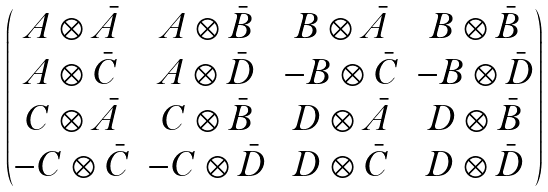Convert formula to latex. <formula><loc_0><loc_0><loc_500><loc_500>\begin{pmatrix} A \otimes \bar { A } & A \otimes \bar { B } & B \otimes \bar { A } & B \otimes \bar { B } \\ A \otimes \bar { C } & A \otimes \bar { D } & - B \otimes \bar { C } & - B \otimes \bar { D } \\ C \otimes \bar { A } & C \otimes \bar { B } & D \otimes \bar { A } & D \otimes \bar { B } \\ - C \otimes \bar { C } & - C \otimes \bar { D } & D \otimes \bar { C } & D \otimes \bar { D } \end{pmatrix}</formula> 